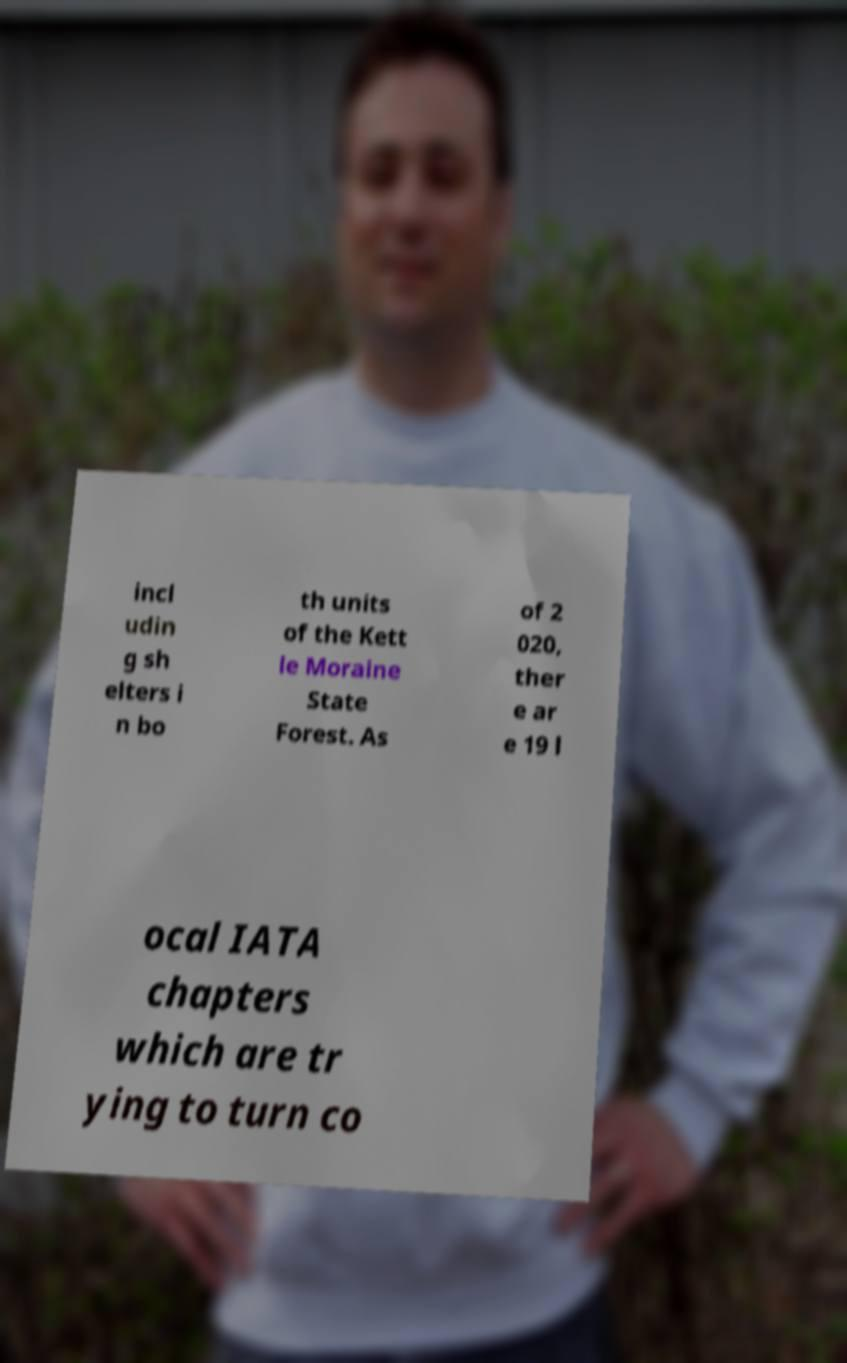Could you extract and type out the text from this image? incl udin g sh elters i n bo th units of the Kett le Moraine State Forest. As of 2 020, ther e ar e 19 l ocal IATA chapters which are tr ying to turn co 